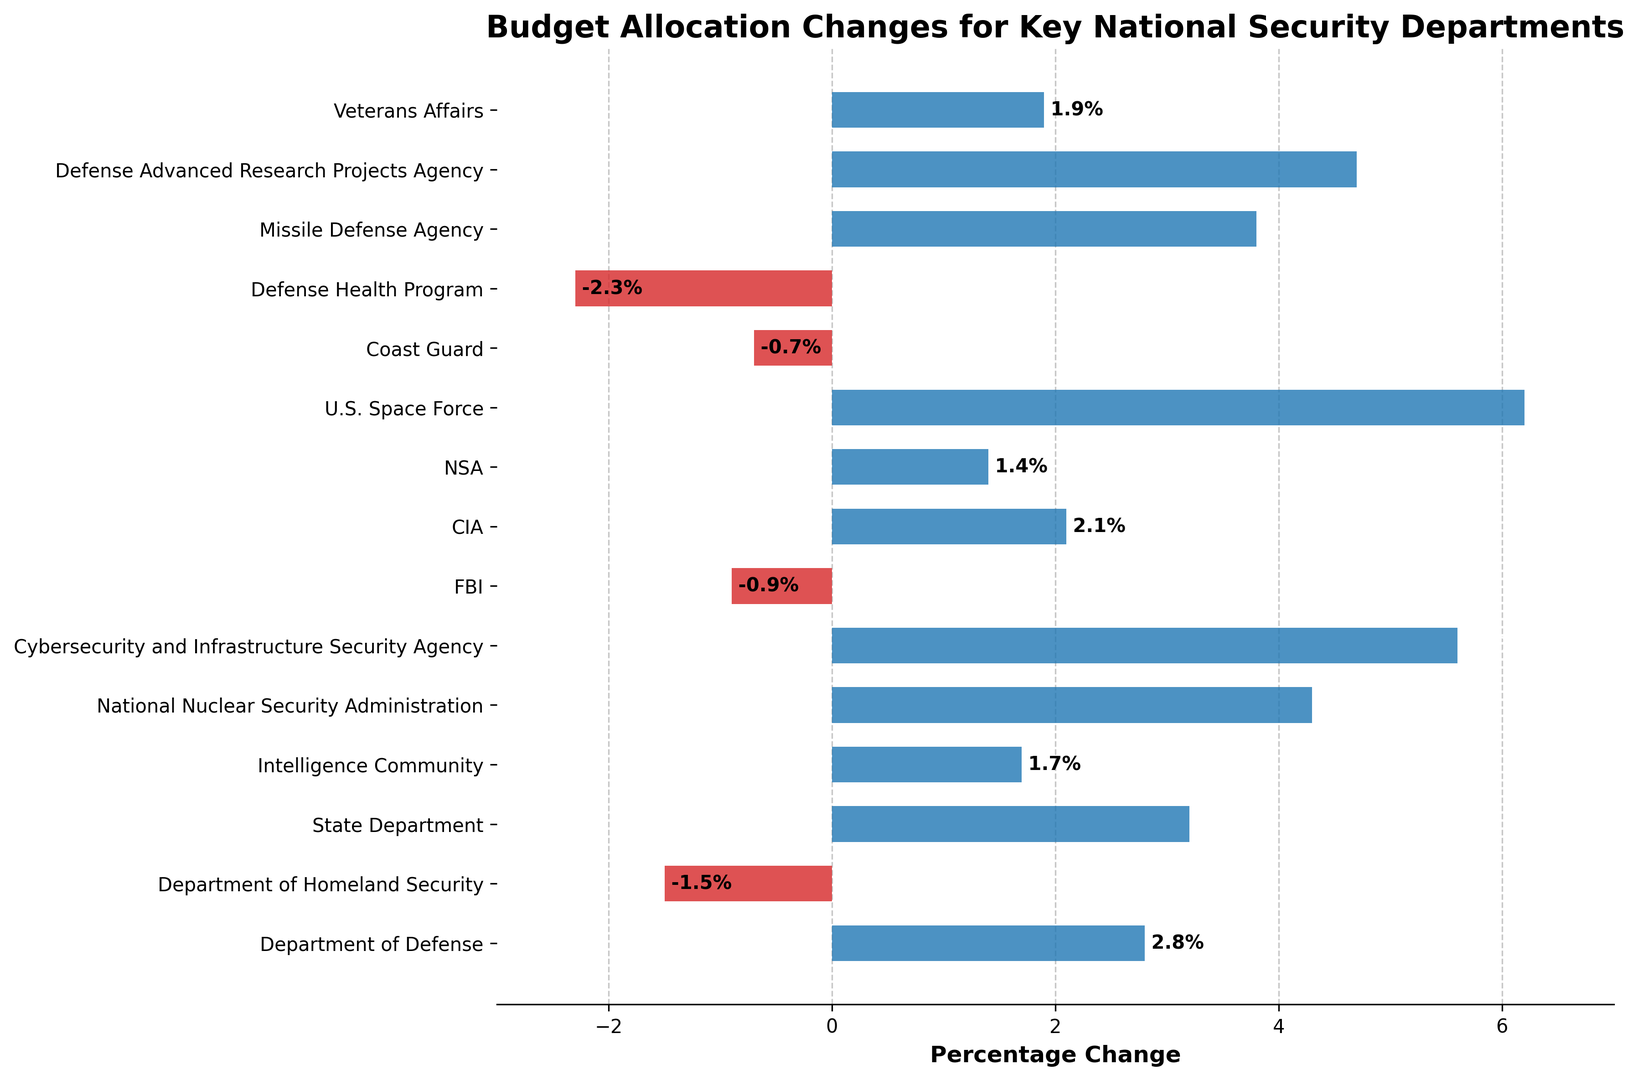Which department experienced the highest budget increase? By looking at the barchart, the department with the longest blue bar in the positive direction represents the highest budget increase.
Answer: U.S. Space Force How many departments had a budget decrease? Count the number of red bars in the chart, as these represent departments with a negative percentage change.
Answer: 3 What is the total percentage change for the departments with a budget decrease? Sum the absolute values of the negative changes: -1.5 (DHS) + -0.9 (FBI) + -0.7 (Coast Guard) + -2.3 (Defense Health Program) = -5.4%.
Answer: -5.4% Which department had a slightly positive budget increase of less than 2%? Identify the department with a blue bar slightly greater than 0 but less than 2: Intelligence Community is 1.7%, NSA is 1.4%, and Veterans Affairs is 1.9%.
Answer: NSA Compare the budget percentage change of the Coast Guard and the Department of Defense. Which had a larger change? Look at the bars for the Coast Guard (-0.7%) and Department of Defense (2.8%) and compare their lengths and color.
Answer: Department of Defense What is the average percentage change for the departments with a positive budget increase? Sum the positive changes and divide by the number of departments with positive increases: (2.8 + 3.2 + 1.7 + 4.3 + 5.6 + 2.1 + 1.4 + 6.2 + 3.8 + 4.7 + 1.9) / 11.
Answer: 3.25% Which department had a budget decrease and still received a relatively smaller reduction? Compare the red bars and find the smallest negative value: FBI is -0.9% and Coast Guard is -0.7%.
Answer: Coast Guard What is the difference in percentage change between the Department of Homeland Security and the Cybersecurity and Infrastructure Security Agency? Subtract DHS's percentage change (-1.5%) from CISA's (5.6%): 5.6 - (-1.5) = 7.1%.
Answer: 7.1% 